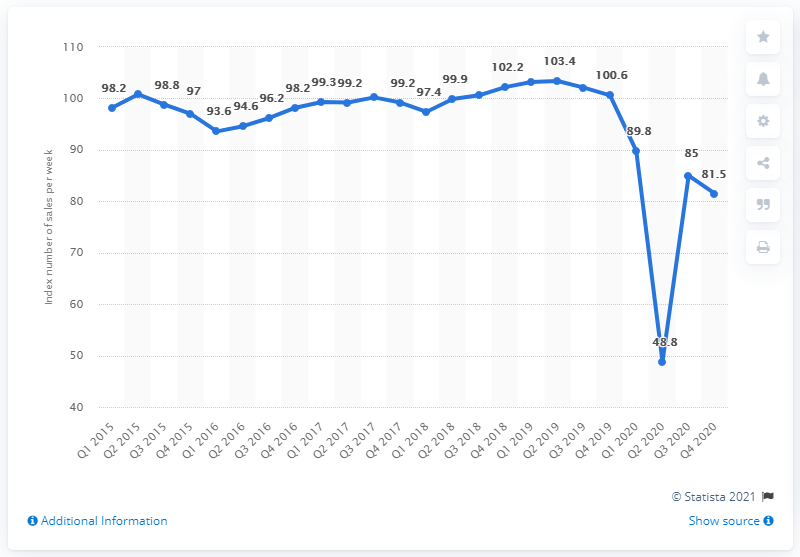Highlight a few significant elements in this photo. In the second quarter of 2019, the retail sales index was 103.4. During the period from Q1 2020 to Q3 2020, the quarter with the greatest increase in sales volume was Q2 2020. The trough value is 48.8. 